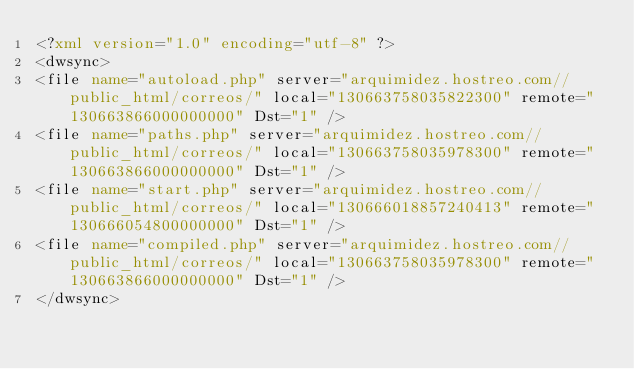<code> <loc_0><loc_0><loc_500><loc_500><_XML_><?xml version="1.0" encoding="utf-8" ?>
<dwsync>
<file name="autoload.php" server="arquimidez.hostreo.com//public_html/correos/" local="130663758035822300" remote="130663866000000000" Dst="1" />
<file name="paths.php" server="arquimidez.hostreo.com//public_html/correos/" local="130663758035978300" remote="130663866000000000" Dst="1" />
<file name="start.php" server="arquimidez.hostreo.com//public_html/correos/" local="130666018857240413" remote="130666054800000000" Dst="1" />
<file name="compiled.php" server="arquimidez.hostreo.com//public_html/correos/" local="130663758035978300" remote="130663866000000000" Dst="1" />
</dwsync></code> 